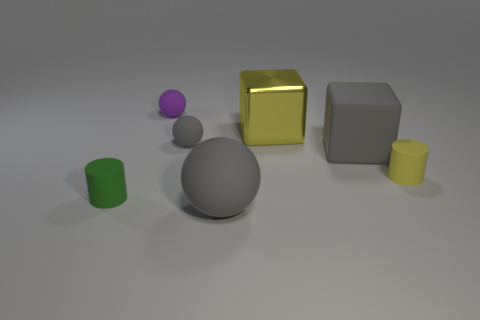Is the shape of the purple thing the same as the tiny gray matte object?
Keep it short and to the point. Yes. How many small purple rubber spheres are on the right side of the gray rubber block?
Offer a terse response. 0. The tiny green thing left of the small rubber ball that is behind the yellow shiny block is what shape?
Your answer should be very brief. Cylinder. What shape is the tiny yellow thing that is the same material as the big gray cube?
Ensure brevity in your answer.  Cylinder. Do the cylinder behind the small green matte thing and the matte object behind the metallic block have the same size?
Provide a short and direct response. Yes. There is a green thing on the left side of the large rubber ball; what shape is it?
Offer a terse response. Cylinder. The metal cube is what color?
Provide a succinct answer. Yellow. There is a purple sphere; is it the same size as the gray ball that is in front of the tiny green matte thing?
Give a very brief answer. No. How many matte objects are big gray objects or small purple balls?
Give a very brief answer. 3. Is there any other thing that has the same material as the big yellow object?
Give a very brief answer. No. 